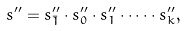Convert formula to latex. <formula><loc_0><loc_0><loc_500><loc_500>s ^ { \prime \prime } = s ^ { \prime \prime } _ { \bar { 1 } } \cdot s ^ { \prime \prime } _ { 0 } \cdot s ^ { \prime \prime } _ { 1 } \cdot \dots \cdot s ^ { \prime \prime } _ { k } ,</formula> 